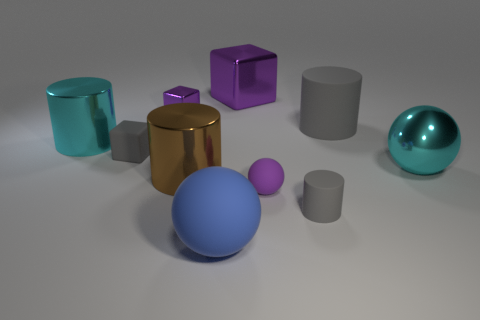Subtract all cyan metallic cylinders. How many cylinders are left? 3 Subtract all gray cubes. How many gray cylinders are left? 2 Subtract all purple blocks. How many blocks are left? 1 Subtract 2 blocks. How many blocks are left? 1 Subtract all purple balls. Subtract all green cylinders. How many balls are left? 2 Subtract all tiny objects. Subtract all tiny purple rubber objects. How many objects are left? 5 Add 1 tiny metallic objects. How many tiny metallic objects are left? 2 Add 8 big brown shiny blocks. How many big brown shiny blocks exist? 8 Subtract 1 blue balls. How many objects are left? 9 Subtract all cubes. How many objects are left? 7 